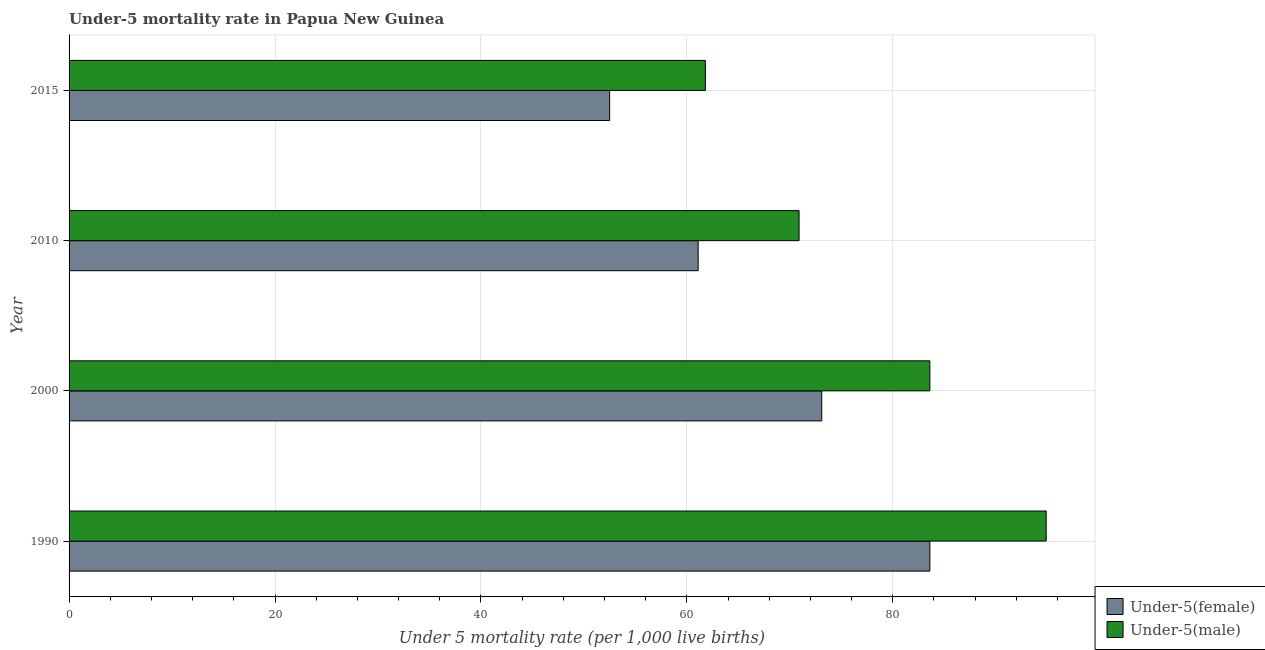How many groups of bars are there?
Give a very brief answer. 4. How many bars are there on the 4th tick from the top?
Your answer should be very brief. 2. How many bars are there on the 4th tick from the bottom?
Your answer should be compact. 2. What is the label of the 1st group of bars from the top?
Offer a terse response. 2015. In how many cases, is the number of bars for a given year not equal to the number of legend labels?
Your answer should be very brief. 0. What is the under-5 female mortality rate in 2000?
Give a very brief answer. 73.1. Across all years, what is the maximum under-5 male mortality rate?
Provide a short and direct response. 94.9. Across all years, what is the minimum under-5 female mortality rate?
Keep it short and to the point. 52.5. In which year was the under-5 female mortality rate maximum?
Give a very brief answer. 1990. In which year was the under-5 female mortality rate minimum?
Keep it short and to the point. 2015. What is the total under-5 female mortality rate in the graph?
Provide a short and direct response. 270.3. What is the difference between the under-5 female mortality rate in 2000 and that in 2015?
Make the answer very short. 20.6. What is the difference between the under-5 male mortality rate in 1990 and the under-5 female mortality rate in 2010?
Provide a short and direct response. 33.8. What is the average under-5 female mortality rate per year?
Your answer should be compact. 67.58. In how many years, is the under-5 male mortality rate greater than 68 ?
Your answer should be compact. 3. What is the ratio of the under-5 male mortality rate in 1990 to that in 2015?
Your answer should be very brief. 1.54. Is the under-5 male mortality rate in 1990 less than that in 2000?
Ensure brevity in your answer.  No. Is the difference between the under-5 male mortality rate in 2000 and 2015 greater than the difference between the under-5 female mortality rate in 2000 and 2015?
Make the answer very short. Yes. What is the difference between the highest and the lowest under-5 male mortality rate?
Make the answer very short. 33.1. Is the sum of the under-5 female mortality rate in 1990 and 2000 greater than the maximum under-5 male mortality rate across all years?
Your answer should be compact. Yes. What does the 2nd bar from the top in 2015 represents?
Keep it short and to the point. Under-5(female). What does the 1st bar from the bottom in 2000 represents?
Offer a very short reply. Under-5(female). How many bars are there?
Provide a short and direct response. 8. How many years are there in the graph?
Provide a short and direct response. 4. What is the difference between two consecutive major ticks on the X-axis?
Provide a succinct answer. 20. Does the graph contain grids?
Make the answer very short. Yes. How many legend labels are there?
Provide a short and direct response. 2. How are the legend labels stacked?
Your answer should be very brief. Vertical. What is the title of the graph?
Your answer should be very brief. Under-5 mortality rate in Papua New Guinea. Does "Enforce a contract" appear as one of the legend labels in the graph?
Ensure brevity in your answer.  No. What is the label or title of the X-axis?
Provide a succinct answer. Under 5 mortality rate (per 1,0 live births). What is the label or title of the Y-axis?
Make the answer very short. Year. What is the Under 5 mortality rate (per 1,000 live births) of Under-5(female) in 1990?
Provide a succinct answer. 83.6. What is the Under 5 mortality rate (per 1,000 live births) of Under-5(male) in 1990?
Your answer should be very brief. 94.9. What is the Under 5 mortality rate (per 1,000 live births) of Under-5(female) in 2000?
Your response must be concise. 73.1. What is the Under 5 mortality rate (per 1,000 live births) of Under-5(male) in 2000?
Offer a terse response. 83.6. What is the Under 5 mortality rate (per 1,000 live births) of Under-5(female) in 2010?
Provide a succinct answer. 61.1. What is the Under 5 mortality rate (per 1,000 live births) of Under-5(male) in 2010?
Provide a succinct answer. 70.9. What is the Under 5 mortality rate (per 1,000 live births) in Under-5(female) in 2015?
Make the answer very short. 52.5. What is the Under 5 mortality rate (per 1,000 live births) of Under-5(male) in 2015?
Offer a very short reply. 61.8. Across all years, what is the maximum Under 5 mortality rate (per 1,000 live births) of Under-5(female)?
Provide a succinct answer. 83.6. Across all years, what is the maximum Under 5 mortality rate (per 1,000 live births) of Under-5(male)?
Your response must be concise. 94.9. Across all years, what is the minimum Under 5 mortality rate (per 1,000 live births) in Under-5(female)?
Provide a succinct answer. 52.5. Across all years, what is the minimum Under 5 mortality rate (per 1,000 live births) of Under-5(male)?
Your response must be concise. 61.8. What is the total Under 5 mortality rate (per 1,000 live births) in Under-5(female) in the graph?
Your answer should be compact. 270.3. What is the total Under 5 mortality rate (per 1,000 live births) of Under-5(male) in the graph?
Provide a short and direct response. 311.2. What is the difference between the Under 5 mortality rate (per 1,000 live births) in Under-5(female) in 1990 and that in 2000?
Offer a terse response. 10.5. What is the difference between the Under 5 mortality rate (per 1,000 live births) of Under-5(female) in 1990 and that in 2010?
Ensure brevity in your answer.  22.5. What is the difference between the Under 5 mortality rate (per 1,000 live births) of Under-5(male) in 1990 and that in 2010?
Offer a very short reply. 24. What is the difference between the Under 5 mortality rate (per 1,000 live births) in Under-5(female) in 1990 and that in 2015?
Your answer should be very brief. 31.1. What is the difference between the Under 5 mortality rate (per 1,000 live births) in Under-5(male) in 1990 and that in 2015?
Offer a very short reply. 33.1. What is the difference between the Under 5 mortality rate (per 1,000 live births) in Under-5(female) in 2000 and that in 2010?
Make the answer very short. 12. What is the difference between the Under 5 mortality rate (per 1,000 live births) in Under-5(female) in 2000 and that in 2015?
Your response must be concise. 20.6. What is the difference between the Under 5 mortality rate (per 1,000 live births) of Under-5(male) in 2000 and that in 2015?
Provide a succinct answer. 21.8. What is the difference between the Under 5 mortality rate (per 1,000 live births) of Under-5(female) in 2010 and that in 2015?
Provide a short and direct response. 8.6. What is the difference between the Under 5 mortality rate (per 1,000 live births) in Under-5(male) in 2010 and that in 2015?
Ensure brevity in your answer.  9.1. What is the difference between the Under 5 mortality rate (per 1,000 live births) of Under-5(female) in 1990 and the Under 5 mortality rate (per 1,000 live births) of Under-5(male) in 2010?
Make the answer very short. 12.7. What is the difference between the Under 5 mortality rate (per 1,000 live births) in Under-5(female) in 1990 and the Under 5 mortality rate (per 1,000 live births) in Under-5(male) in 2015?
Give a very brief answer. 21.8. What is the difference between the Under 5 mortality rate (per 1,000 live births) of Under-5(female) in 2000 and the Under 5 mortality rate (per 1,000 live births) of Under-5(male) in 2015?
Offer a very short reply. 11.3. What is the difference between the Under 5 mortality rate (per 1,000 live births) in Under-5(female) in 2010 and the Under 5 mortality rate (per 1,000 live births) in Under-5(male) in 2015?
Your response must be concise. -0.7. What is the average Under 5 mortality rate (per 1,000 live births) in Under-5(female) per year?
Make the answer very short. 67.58. What is the average Under 5 mortality rate (per 1,000 live births) in Under-5(male) per year?
Your answer should be very brief. 77.8. In the year 1990, what is the difference between the Under 5 mortality rate (per 1,000 live births) of Under-5(female) and Under 5 mortality rate (per 1,000 live births) of Under-5(male)?
Give a very brief answer. -11.3. In the year 2000, what is the difference between the Under 5 mortality rate (per 1,000 live births) of Under-5(female) and Under 5 mortality rate (per 1,000 live births) of Under-5(male)?
Provide a short and direct response. -10.5. What is the ratio of the Under 5 mortality rate (per 1,000 live births) in Under-5(female) in 1990 to that in 2000?
Provide a short and direct response. 1.14. What is the ratio of the Under 5 mortality rate (per 1,000 live births) of Under-5(male) in 1990 to that in 2000?
Give a very brief answer. 1.14. What is the ratio of the Under 5 mortality rate (per 1,000 live births) of Under-5(female) in 1990 to that in 2010?
Offer a very short reply. 1.37. What is the ratio of the Under 5 mortality rate (per 1,000 live births) in Under-5(male) in 1990 to that in 2010?
Offer a terse response. 1.34. What is the ratio of the Under 5 mortality rate (per 1,000 live births) in Under-5(female) in 1990 to that in 2015?
Offer a terse response. 1.59. What is the ratio of the Under 5 mortality rate (per 1,000 live births) in Under-5(male) in 1990 to that in 2015?
Keep it short and to the point. 1.54. What is the ratio of the Under 5 mortality rate (per 1,000 live births) in Under-5(female) in 2000 to that in 2010?
Give a very brief answer. 1.2. What is the ratio of the Under 5 mortality rate (per 1,000 live births) of Under-5(male) in 2000 to that in 2010?
Provide a short and direct response. 1.18. What is the ratio of the Under 5 mortality rate (per 1,000 live births) in Under-5(female) in 2000 to that in 2015?
Offer a terse response. 1.39. What is the ratio of the Under 5 mortality rate (per 1,000 live births) in Under-5(male) in 2000 to that in 2015?
Keep it short and to the point. 1.35. What is the ratio of the Under 5 mortality rate (per 1,000 live births) of Under-5(female) in 2010 to that in 2015?
Offer a very short reply. 1.16. What is the ratio of the Under 5 mortality rate (per 1,000 live births) of Under-5(male) in 2010 to that in 2015?
Keep it short and to the point. 1.15. What is the difference between the highest and the second highest Under 5 mortality rate (per 1,000 live births) of Under-5(female)?
Your answer should be compact. 10.5. What is the difference between the highest and the lowest Under 5 mortality rate (per 1,000 live births) in Under-5(female)?
Your response must be concise. 31.1. What is the difference between the highest and the lowest Under 5 mortality rate (per 1,000 live births) in Under-5(male)?
Your answer should be very brief. 33.1. 